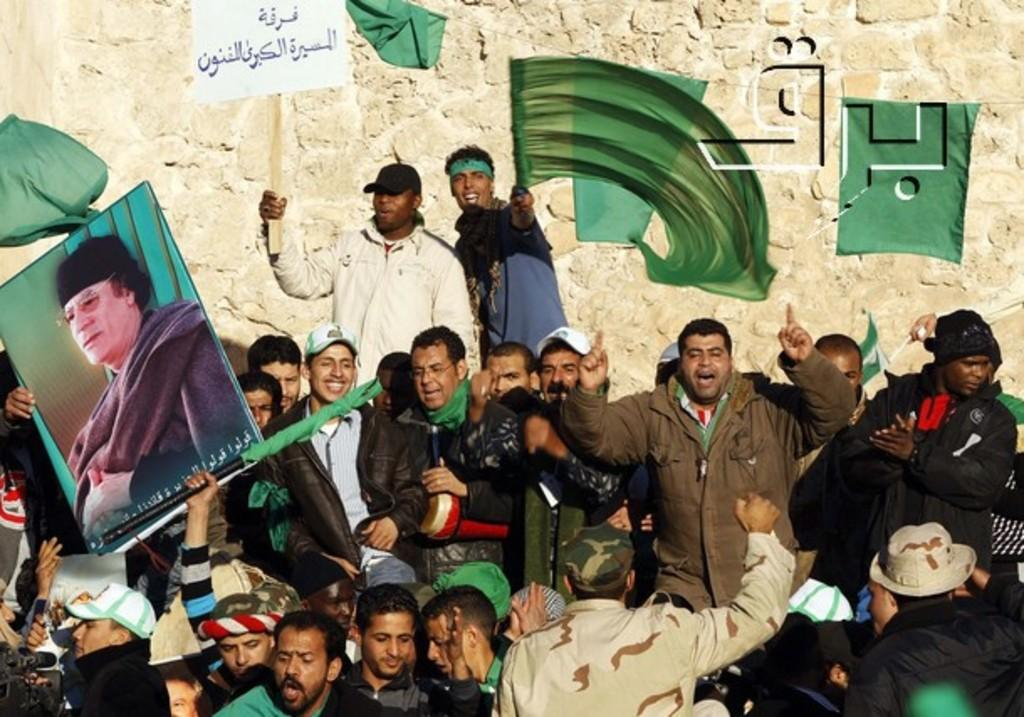How many people are in the image? There is a group of people in the image, but the exact number is not specified. What are some of the people holding in the image? Some of the people are holding boards and flags in the image. What are some of the people doing in the image? Some of the people are shouting in the image. What can be seen in the background of the image? There is a wall in the background of the image. What type of reading material is being passed around among the people in the image? There is no reading material visible in the image; people are holding boards and flags. What suggestions are being made by the people holding notebooks in the image? There are no notebooks present in the image. 